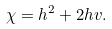Convert formula to latex. <formula><loc_0><loc_0><loc_500><loc_500>\chi = h ^ { 2 } + 2 h v .</formula> 